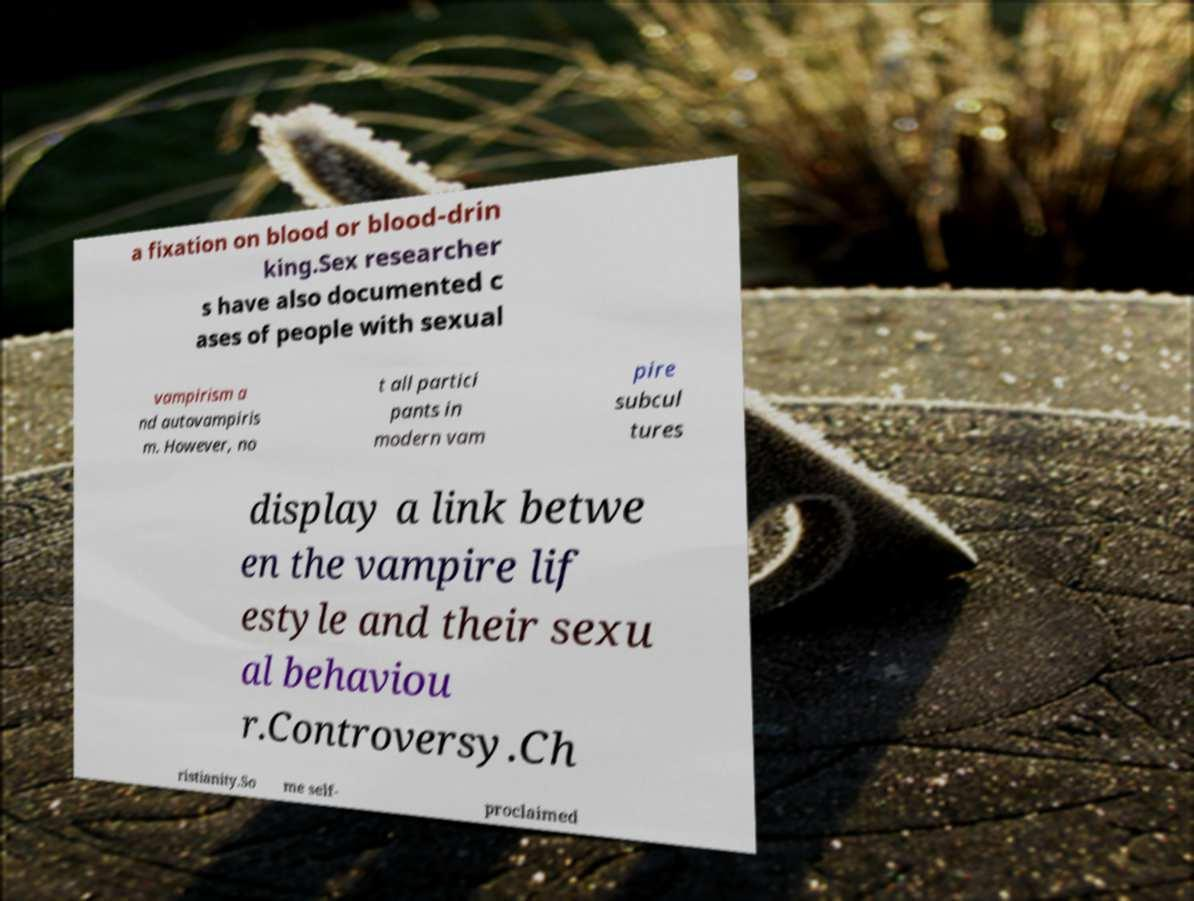For documentation purposes, I need the text within this image transcribed. Could you provide that? a fixation on blood or blood-drin king.Sex researcher s have also documented c ases of people with sexual vampirism a nd autovampiris m. However, no t all partici pants in modern vam pire subcul tures display a link betwe en the vampire lif estyle and their sexu al behaviou r.Controversy.Ch ristianity.So me self- proclaimed 